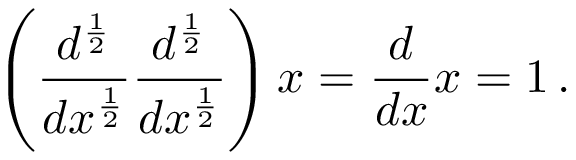Convert formula to latex. <formula><loc_0><loc_0><loc_500><loc_500>\left ( { \frac { d ^ { \frac { 1 } { 2 } } } { d x ^ { \frac { 1 } { 2 } } } } { \frac { d ^ { \frac { 1 } { 2 } } } { d x ^ { \frac { 1 } { 2 } } } } \right ) x = { \frac { d } { d x } } x = 1 \, .</formula> 